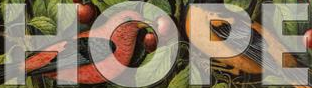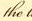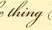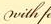What words can you see in these images in sequence, separated by a semicolon? HOPE; the; thing; with 